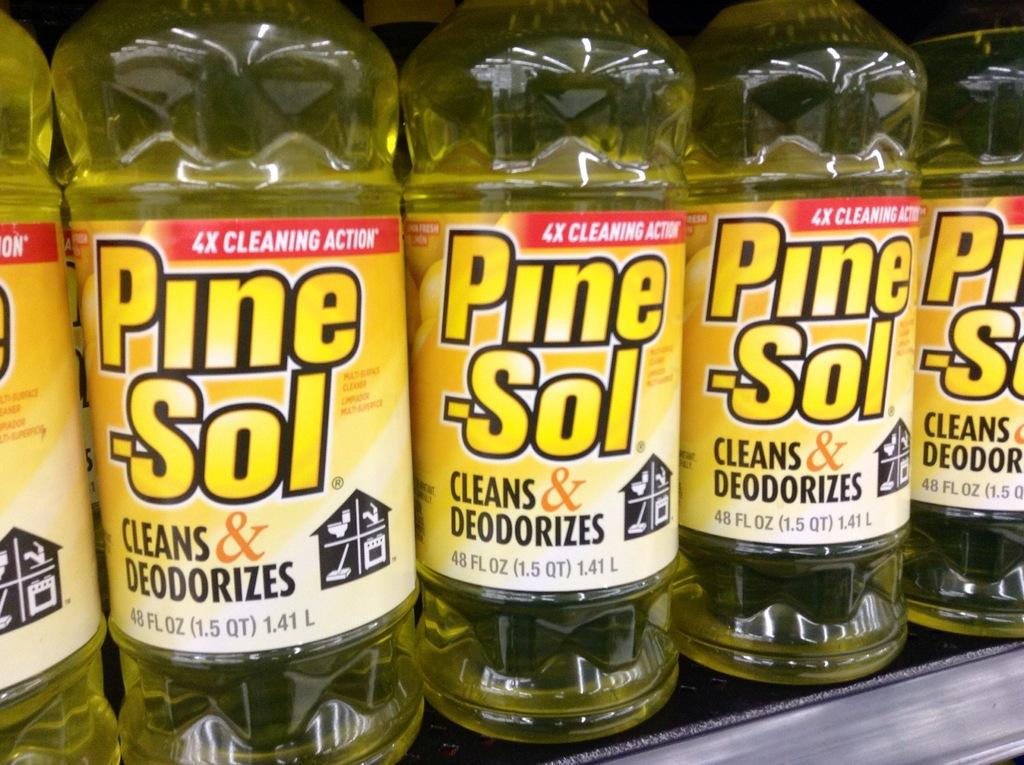<image>
Write a terse but informative summary of the picture. Several bottles of Pine-Sol lined up on a shelf 